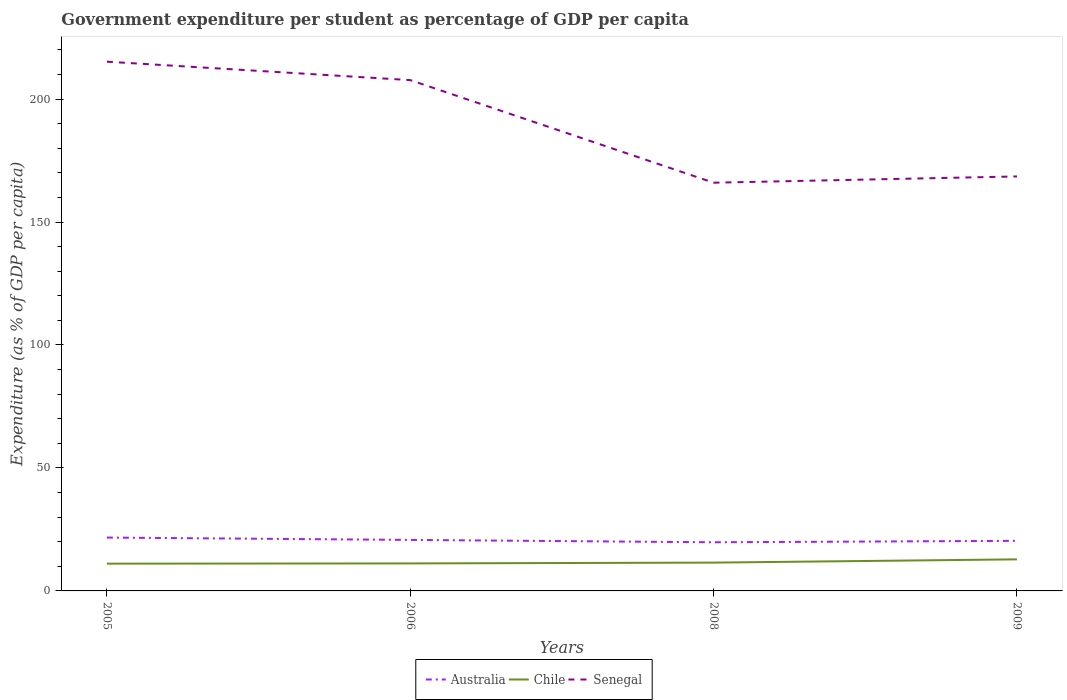How many different coloured lines are there?
Give a very brief answer. 3. Does the line corresponding to Chile intersect with the line corresponding to Australia?
Provide a succinct answer. No. Is the number of lines equal to the number of legend labels?
Offer a very short reply. Yes. Across all years, what is the maximum percentage of expenditure per student in Chile?
Keep it short and to the point. 11.09. What is the total percentage of expenditure per student in Australia in the graph?
Offer a terse response. 0.95. What is the difference between the highest and the second highest percentage of expenditure per student in Chile?
Make the answer very short. 1.74. Is the percentage of expenditure per student in Senegal strictly greater than the percentage of expenditure per student in Australia over the years?
Offer a very short reply. No. Are the values on the major ticks of Y-axis written in scientific E-notation?
Give a very brief answer. No. What is the title of the graph?
Ensure brevity in your answer.  Government expenditure per student as percentage of GDP per capita. What is the label or title of the X-axis?
Your answer should be compact. Years. What is the label or title of the Y-axis?
Offer a terse response. Expenditure (as % of GDP per capita). What is the Expenditure (as % of GDP per capita) in Australia in 2005?
Your answer should be compact. 21.7. What is the Expenditure (as % of GDP per capita) in Chile in 2005?
Offer a terse response. 11.09. What is the Expenditure (as % of GDP per capita) in Senegal in 2005?
Your response must be concise. 215.21. What is the Expenditure (as % of GDP per capita) in Australia in 2006?
Your answer should be compact. 20.74. What is the Expenditure (as % of GDP per capita) in Chile in 2006?
Offer a terse response. 11.18. What is the Expenditure (as % of GDP per capita) of Senegal in 2006?
Your answer should be compact. 207.71. What is the Expenditure (as % of GDP per capita) in Australia in 2008?
Give a very brief answer. 19.78. What is the Expenditure (as % of GDP per capita) in Chile in 2008?
Your answer should be compact. 11.51. What is the Expenditure (as % of GDP per capita) of Senegal in 2008?
Your answer should be compact. 166. What is the Expenditure (as % of GDP per capita) of Australia in 2009?
Offer a very short reply. 20.37. What is the Expenditure (as % of GDP per capita) in Chile in 2009?
Give a very brief answer. 12.83. What is the Expenditure (as % of GDP per capita) in Senegal in 2009?
Offer a very short reply. 168.54. Across all years, what is the maximum Expenditure (as % of GDP per capita) of Australia?
Give a very brief answer. 21.7. Across all years, what is the maximum Expenditure (as % of GDP per capita) in Chile?
Keep it short and to the point. 12.83. Across all years, what is the maximum Expenditure (as % of GDP per capita) in Senegal?
Offer a terse response. 215.21. Across all years, what is the minimum Expenditure (as % of GDP per capita) of Australia?
Your answer should be compact. 19.78. Across all years, what is the minimum Expenditure (as % of GDP per capita) of Chile?
Provide a short and direct response. 11.09. Across all years, what is the minimum Expenditure (as % of GDP per capita) of Senegal?
Your response must be concise. 166. What is the total Expenditure (as % of GDP per capita) of Australia in the graph?
Give a very brief answer. 82.59. What is the total Expenditure (as % of GDP per capita) in Chile in the graph?
Offer a terse response. 46.61. What is the total Expenditure (as % of GDP per capita) of Senegal in the graph?
Your response must be concise. 757.46. What is the difference between the Expenditure (as % of GDP per capita) in Australia in 2005 and that in 2006?
Make the answer very short. 0.95. What is the difference between the Expenditure (as % of GDP per capita) in Chile in 2005 and that in 2006?
Your response must be concise. -0.09. What is the difference between the Expenditure (as % of GDP per capita) of Senegal in 2005 and that in 2006?
Give a very brief answer. 7.5. What is the difference between the Expenditure (as % of GDP per capita) in Australia in 2005 and that in 2008?
Your response must be concise. 1.91. What is the difference between the Expenditure (as % of GDP per capita) in Chile in 2005 and that in 2008?
Offer a very short reply. -0.42. What is the difference between the Expenditure (as % of GDP per capita) in Senegal in 2005 and that in 2008?
Your answer should be very brief. 49.21. What is the difference between the Expenditure (as % of GDP per capita) of Australia in 2005 and that in 2009?
Provide a succinct answer. 1.33. What is the difference between the Expenditure (as % of GDP per capita) in Chile in 2005 and that in 2009?
Give a very brief answer. -1.74. What is the difference between the Expenditure (as % of GDP per capita) in Senegal in 2005 and that in 2009?
Your response must be concise. 46.67. What is the difference between the Expenditure (as % of GDP per capita) of Australia in 2006 and that in 2008?
Provide a short and direct response. 0.96. What is the difference between the Expenditure (as % of GDP per capita) in Chile in 2006 and that in 2008?
Keep it short and to the point. -0.33. What is the difference between the Expenditure (as % of GDP per capita) of Senegal in 2006 and that in 2008?
Give a very brief answer. 41.72. What is the difference between the Expenditure (as % of GDP per capita) in Australia in 2006 and that in 2009?
Offer a terse response. 0.38. What is the difference between the Expenditure (as % of GDP per capita) of Chile in 2006 and that in 2009?
Your answer should be compact. -1.65. What is the difference between the Expenditure (as % of GDP per capita) of Senegal in 2006 and that in 2009?
Your answer should be very brief. 39.17. What is the difference between the Expenditure (as % of GDP per capita) of Australia in 2008 and that in 2009?
Make the answer very short. -0.58. What is the difference between the Expenditure (as % of GDP per capita) of Chile in 2008 and that in 2009?
Your answer should be compact. -1.32. What is the difference between the Expenditure (as % of GDP per capita) in Senegal in 2008 and that in 2009?
Keep it short and to the point. -2.55. What is the difference between the Expenditure (as % of GDP per capita) of Australia in 2005 and the Expenditure (as % of GDP per capita) of Chile in 2006?
Give a very brief answer. 10.52. What is the difference between the Expenditure (as % of GDP per capita) in Australia in 2005 and the Expenditure (as % of GDP per capita) in Senegal in 2006?
Make the answer very short. -186.02. What is the difference between the Expenditure (as % of GDP per capita) in Chile in 2005 and the Expenditure (as % of GDP per capita) in Senegal in 2006?
Your response must be concise. -196.63. What is the difference between the Expenditure (as % of GDP per capita) of Australia in 2005 and the Expenditure (as % of GDP per capita) of Chile in 2008?
Offer a very short reply. 10.19. What is the difference between the Expenditure (as % of GDP per capita) of Australia in 2005 and the Expenditure (as % of GDP per capita) of Senegal in 2008?
Ensure brevity in your answer.  -144.3. What is the difference between the Expenditure (as % of GDP per capita) of Chile in 2005 and the Expenditure (as % of GDP per capita) of Senegal in 2008?
Give a very brief answer. -154.91. What is the difference between the Expenditure (as % of GDP per capita) of Australia in 2005 and the Expenditure (as % of GDP per capita) of Chile in 2009?
Your answer should be very brief. 8.86. What is the difference between the Expenditure (as % of GDP per capita) in Australia in 2005 and the Expenditure (as % of GDP per capita) in Senegal in 2009?
Provide a short and direct response. -146.85. What is the difference between the Expenditure (as % of GDP per capita) of Chile in 2005 and the Expenditure (as % of GDP per capita) of Senegal in 2009?
Provide a succinct answer. -157.45. What is the difference between the Expenditure (as % of GDP per capita) in Australia in 2006 and the Expenditure (as % of GDP per capita) in Chile in 2008?
Your answer should be compact. 9.23. What is the difference between the Expenditure (as % of GDP per capita) of Australia in 2006 and the Expenditure (as % of GDP per capita) of Senegal in 2008?
Your response must be concise. -145.25. What is the difference between the Expenditure (as % of GDP per capita) of Chile in 2006 and the Expenditure (as % of GDP per capita) of Senegal in 2008?
Your response must be concise. -154.82. What is the difference between the Expenditure (as % of GDP per capita) in Australia in 2006 and the Expenditure (as % of GDP per capita) in Chile in 2009?
Provide a succinct answer. 7.91. What is the difference between the Expenditure (as % of GDP per capita) of Australia in 2006 and the Expenditure (as % of GDP per capita) of Senegal in 2009?
Give a very brief answer. -147.8. What is the difference between the Expenditure (as % of GDP per capita) of Chile in 2006 and the Expenditure (as % of GDP per capita) of Senegal in 2009?
Your response must be concise. -157.36. What is the difference between the Expenditure (as % of GDP per capita) in Australia in 2008 and the Expenditure (as % of GDP per capita) in Chile in 2009?
Ensure brevity in your answer.  6.95. What is the difference between the Expenditure (as % of GDP per capita) in Australia in 2008 and the Expenditure (as % of GDP per capita) in Senegal in 2009?
Your response must be concise. -148.76. What is the difference between the Expenditure (as % of GDP per capita) in Chile in 2008 and the Expenditure (as % of GDP per capita) in Senegal in 2009?
Give a very brief answer. -157.03. What is the average Expenditure (as % of GDP per capita) in Australia per year?
Keep it short and to the point. 20.65. What is the average Expenditure (as % of GDP per capita) of Chile per year?
Ensure brevity in your answer.  11.65. What is the average Expenditure (as % of GDP per capita) in Senegal per year?
Offer a very short reply. 189.37. In the year 2005, what is the difference between the Expenditure (as % of GDP per capita) of Australia and Expenditure (as % of GDP per capita) of Chile?
Ensure brevity in your answer.  10.61. In the year 2005, what is the difference between the Expenditure (as % of GDP per capita) of Australia and Expenditure (as % of GDP per capita) of Senegal?
Your answer should be compact. -193.51. In the year 2005, what is the difference between the Expenditure (as % of GDP per capita) of Chile and Expenditure (as % of GDP per capita) of Senegal?
Your answer should be compact. -204.12. In the year 2006, what is the difference between the Expenditure (as % of GDP per capita) of Australia and Expenditure (as % of GDP per capita) of Chile?
Provide a succinct answer. 9.56. In the year 2006, what is the difference between the Expenditure (as % of GDP per capita) of Australia and Expenditure (as % of GDP per capita) of Senegal?
Give a very brief answer. -186.97. In the year 2006, what is the difference between the Expenditure (as % of GDP per capita) in Chile and Expenditure (as % of GDP per capita) in Senegal?
Provide a short and direct response. -196.53. In the year 2008, what is the difference between the Expenditure (as % of GDP per capita) in Australia and Expenditure (as % of GDP per capita) in Chile?
Offer a very short reply. 8.27. In the year 2008, what is the difference between the Expenditure (as % of GDP per capita) of Australia and Expenditure (as % of GDP per capita) of Senegal?
Offer a terse response. -146.22. In the year 2008, what is the difference between the Expenditure (as % of GDP per capita) of Chile and Expenditure (as % of GDP per capita) of Senegal?
Offer a very short reply. -154.49. In the year 2009, what is the difference between the Expenditure (as % of GDP per capita) of Australia and Expenditure (as % of GDP per capita) of Chile?
Your response must be concise. 7.53. In the year 2009, what is the difference between the Expenditure (as % of GDP per capita) of Australia and Expenditure (as % of GDP per capita) of Senegal?
Ensure brevity in your answer.  -148.18. In the year 2009, what is the difference between the Expenditure (as % of GDP per capita) in Chile and Expenditure (as % of GDP per capita) in Senegal?
Provide a succinct answer. -155.71. What is the ratio of the Expenditure (as % of GDP per capita) of Australia in 2005 to that in 2006?
Your answer should be compact. 1.05. What is the ratio of the Expenditure (as % of GDP per capita) of Senegal in 2005 to that in 2006?
Provide a succinct answer. 1.04. What is the ratio of the Expenditure (as % of GDP per capita) of Australia in 2005 to that in 2008?
Give a very brief answer. 1.1. What is the ratio of the Expenditure (as % of GDP per capita) in Chile in 2005 to that in 2008?
Your response must be concise. 0.96. What is the ratio of the Expenditure (as % of GDP per capita) in Senegal in 2005 to that in 2008?
Provide a succinct answer. 1.3. What is the ratio of the Expenditure (as % of GDP per capita) in Australia in 2005 to that in 2009?
Provide a short and direct response. 1.07. What is the ratio of the Expenditure (as % of GDP per capita) of Chile in 2005 to that in 2009?
Offer a very short reply. 0.86. What is the ratio of the Expenditure (as % of GDP per capita) in Senegal in 2005 to that in 2009?
Your answer should be very brief. 1.28. What is the ratio of the Expenditure (as % of GDP per capita) in Australia in 2006 to that in 2008?
Give a very brief answer. 1.05. What is the ratio of the Expenditure (as % of GDP per capita) in Chile in 2006 to that in 2008?
Keep it short and to the point. 0.97. What is the ratio of the Expenditure (as % of GDP per capita) of Senegal in 2006 to that in 2008?
Give a very brief answer. 1.25. What is the ratio of the Expenditure (as % of GDP per capita) in Australia in 2006 to that in 2009?
Provide a succinct answer. 1.02. What is the ratio of the Expenditure (as % of GDP per capita) in Chile in 2006 to that in 2009?
Offer a very short reply. 0.87. What is the ratio of the Expenditure (as % of GDP per capita) in Senegal in 2006 to that in 2009?
Give a very brief answer. 1.23. What is the ratio of the Expenditure (as % of GDP per capita) of Australia in 2008 to that in 2009?
Offer a very short reply. 0.97. What is the ratio of the Expenditure (as % of GDP per capita) of Chile in 2008 to that in 2009?
Give a very brief answer. 0.9. What is the ratio of the Expenditure (as % of GDP per capita) of Senegal in 2008 to that in 2009?
Ensure brevity in your answer.  0.98. What is the difference between the highest and the second highest Expenditure (as % of GDP per capita) of Australia?
Your answer should be very brief. 0.95. What is the difference between the highest and the second highest Expenditure (as % of GDP per capita) of Chile?
Offer a very short reply. 1.32. What is the difference between the highest and the second highest Expenditure (as % of GDP per capita) of Senegal?
Keep it short and to the point. 7.5. What is the difference between the highest and the lowest Expenditure (as % of GDP per capita) of Australia?
Provide a short and direct response. 1.91. What is the difference between the highest and the lowest Expenditure (as % of GDP per capita) in Chile?
Your answer should be compact. 1.74. What is the difference between the highest and the lowest Expenditure (as % of GDP per capita) of Senegal?
Your answer should be very brief. 49.21. 